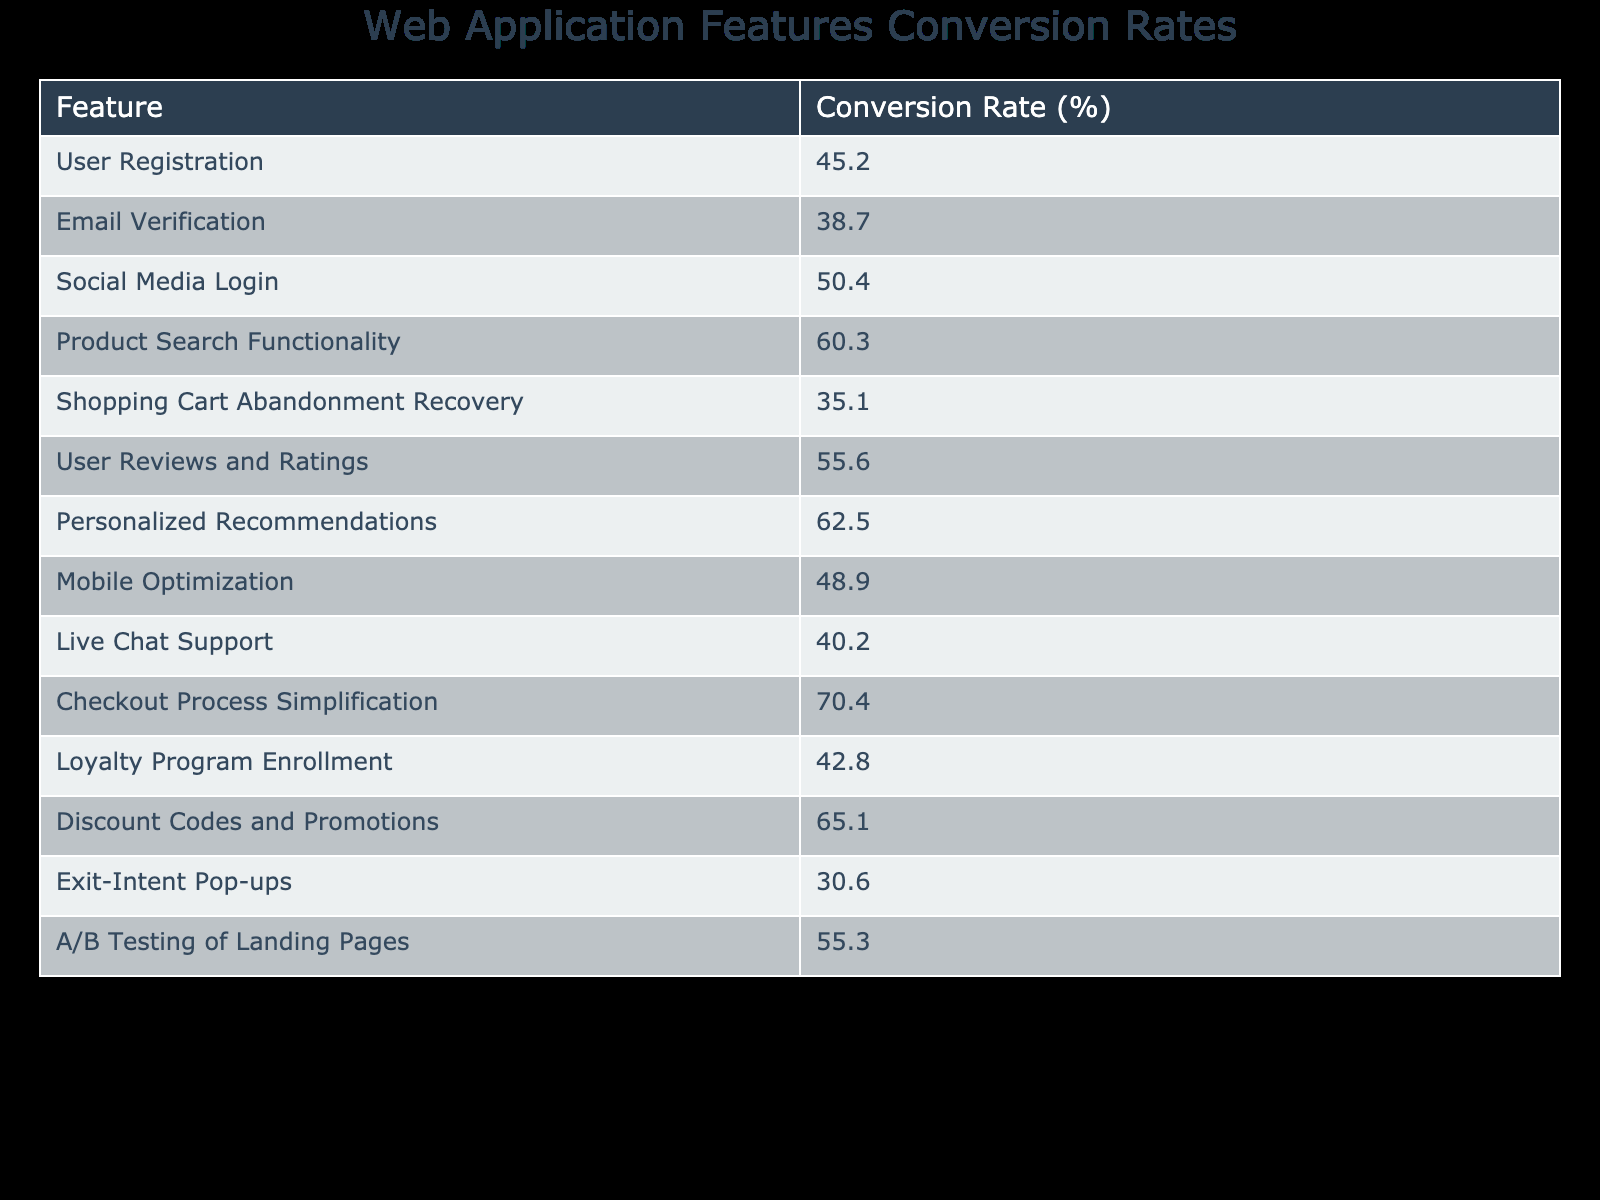What is the conversion rate for User Registration? The conversion rate for User Registration is explicitly listed in the table under the corresponding feature, which shows a value of 45.2%.
Answer: 45.2% What feature has the highest conversion rate? By examining the conversion rates in the table, the feature with the highest rate is Checkout Process Simplification, which has a conversion rate of 70.4%.
Answer: Checkout Process Simplification Is the conversion rate for Mobile Optimization above 50%? Looking at the table, Mobile Optimization has a conversion rate of 48.9%, which is below 50%.
Answer: No What is the average conversion rate of features related to shopping cart functions (Shopping Cart Abandonment Recovery and Checkout Process Simplification)? First, we find the conversion rates for these features: Shopping Cart Abandonment Recovery is 35.1% and Checkout Process Simplification is 70.4%. Summing them gives 35.1 + 70.4 = 105.5%. There are two features, so the average is 105.5% / 2 = 52.75%.
Answer: 52.75% Which feature has a conversion rate that is over 60% but under 70%? Looking at the conversion rates, we find the features: Personalized Recommendations (62.5%) and Discount Codes and Promotions (65.1%). Both of these are between 60% and 70%. Therefore, both features meet this criterion.
Answer: Personalized Recommendations and Discount Codes and Promotions What percentage difference is there between the conversion rates of Social Media Login and Exit-Intent Pop-ups? First, we look at the conversion rates: Social Media Login is 50.4% and Exit-Intent Pop-ups is 30.6%. The difference is calculated as 50.4% - 30.6% = 19.8%. This shows how much higher Social Media Login's rate is compared to Exit-Intent Pop-ups.
Answer: 19.8% Is the conversion rate for Live Chat Support greater than that of Email Verification? The table shows the conversion rate for Live Chat Support is 40.2%, and for Email Verification, it is 38.7%. Since 40.2% is greater than 38.7%, the statement is true.
Answer: Yes What is the conversion rate for A/B Testing of Landing Pages? The conversion rate for A/B Testing of Landing Pages is directly presented in the table as 55.3%.
Answer: 55.3% How many features in total have conversion rates below 40%? Checking the table, we see that the only feature with a conversion rate below 40% is Exit-Intent Pop-ups at 30.6%, which means that there is just one feature that meets this condition.
Answer: 1 